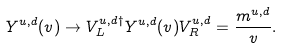Convert formula to latex. <formula><loc_0><loc_0><loc_500><loc_500>Y ^ { u , d } ( v ) \rightarrow V _ { L } ^ { u , d \dagger } Y ^ { u , d } ( v ) V _ { R } ^ { u , d } = \frac { m ^ { u , d } } { v } .</formula> 